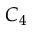<formula> <loc_0><loc_0><loc_500><loc_500>C _ { 4 }</formula> 